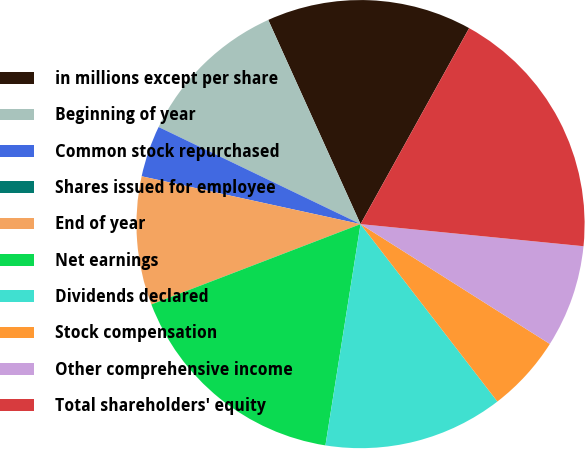Convert chart. <chart><loc_0><loc_0><loc_500><loc_500><pie_chart><fcel>in millions except per share<fcel>Beginning of year<fcel>Common stock repurchased<fcel>Shares issued for employee<fcel>End of year<fcel>Net earnings<fcel>Dividends declared<fcel>Stock compensation<fcel>Other comprehensive income<fcel>Total shareholders' equity<nl><fcel>14.81%<fcel>11.11%<fcel>3.71%<fcel>0.0%<fcel>9.26%<fcel>16.66%<fcel>12.96%<fcel>5.56%<fcel>7.41%<fcel>18.52%<nl></chart> 